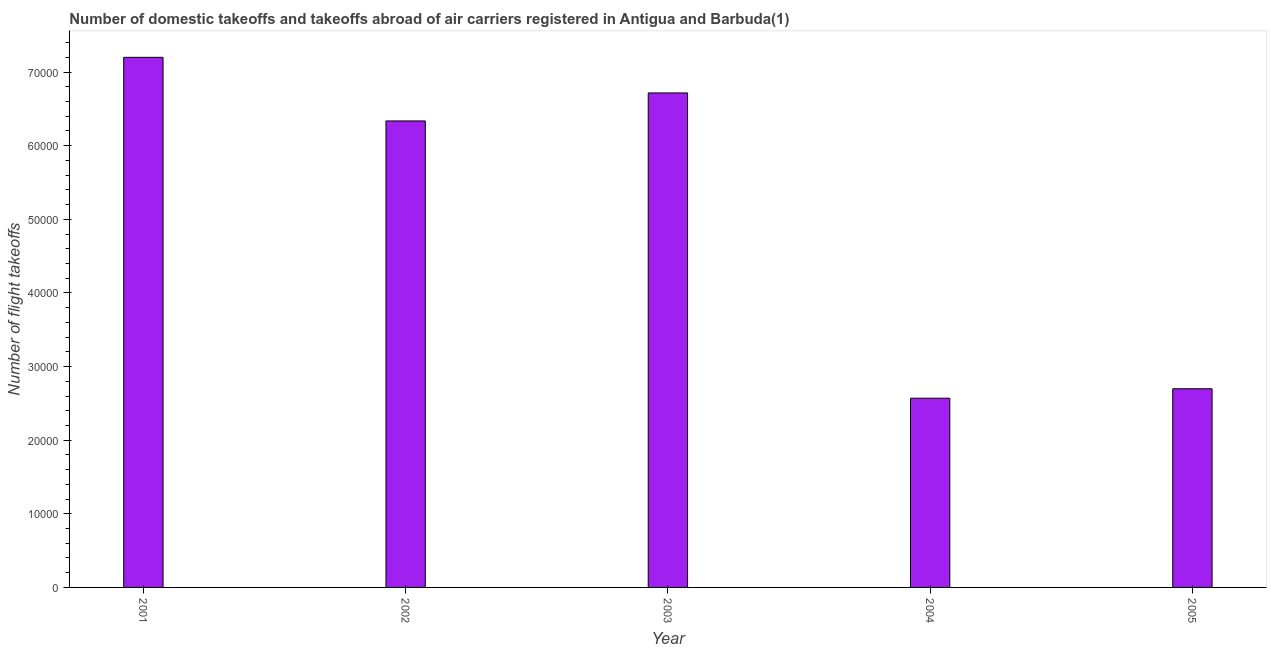What is the title of the graph?
Provide a succinct answer. Number of domestic takeoffs and takeoffs abroad of air carriers registered in Antigua and Barbuda(1). What is the label or title of the Y-axis?
Provide a succinct answer. Number of flight takeoffs. What is the number of flight takeoffs in 2001?
Provide a succinct answer. 7.20e+04. Across all years, what is the maximum number of flight takeoffs?
Provide a succinct answer. 7.20e+04. Across all years, what is the minimum number of flight takeoffs?
Provide a short and direct response. 2.57e+04. In which year was the number of flight takeoffs minimum?
Your answer should be very brief. 2004. What is the sum of the number of flight takeoffs?
Make the answer very short. 2.55e+05. What is the difference between the number of flight takeoffs in 2003 and 2005?
Give a very brief answer. 4.02e+04. What is the average number of flight takeoffs per year?
Offer a terse response. 5.10e+04. What is the median number of flight takeoffs?
Offer a very short reply. 6.34e+04. What is the ratio of the number of flight takeoffs in 2003 to that in 2005?
Keep it short and to the point. 2.49. Is the number of flight takeoffs in 2003 less than that in 2005?
Your response must be concise. No. What is the difference between the highest and the second highest number of flight takeoffs?
Give a very brief answer. 4838. Is the sum of the number of flight takeoffs in 2002 and 2005 greater than the maximum number of flight takeoffs across all years?
Offer a very short reply. Yes. What is the difference between the highest and the lowest number of flight takeoffs?
Offer a terse response. 4.63e+04. Are all the bars in the graph horizontal?
Your answer should be compact. No. How many years are there in the graph?
Your answer should be compact. 5. What is the Number of flight takeoffs in 2001?
Keep it short and to the point. 7.20e+04. What is the Number of flight takeoffs of 2002?
Offer a terse response. 6.34e+04. What is the Number of flight takeoffs in 2003?
Give a very brief answer. 6.72e+04. What is the Number of flight takeoffs in 2004?
Your answer should be very brief. 2.57e+04. What is the Number of flight takeoffs of 2005?
Provide a short and direct response. 2.70e+04. What is the difference between the Number of flight takeoffs in 2001 and 2002?
Provide a succinct answer. 8640. What is the difference between the Number of flight takeoffs in 2001 and 2003?
Your answer should be very brief. 4838. What is the difference between the Number of flight takeoffs in 2001 and 2004?
Ensure brevity in your answer.  4.63e+04. What is the difference between the Number of flight takeoffs in 2001 and 2005?
Give a very brief answer. 4.50e+04. What is the difference between the Number of flight takeoffs in 2002 and 2003?
Ensure brevity in your answer.  -3802. What is the difference between the Number of flight takeoffs in 2002 and 2004?
Ensure brevity in your answer.  3.77e+04. What is the difference between the Number of flight takeoffs in 2002 and 2005?
Keep it short and to the point. 3.64e+04. What is the difference between the Number of flight takeoffs in 2003 and 2004?
Your response must be concise. 4.15e+04. What is the difference between the Number of flight takeoffs in 2003 and 2005?
Your answer should be very brief. 4.02e+04. What is the difference between the Number of flight takeoffs in 2004 and 2005?
Offer a very short reply. -1285. What is the ratio of the Number of flight takeoffs in 2001 to that in 2002?
Keep it short and to the point. 1.14. What is the ratio of the Number of flight takeoffs in 2001 to that in 2003?
Make the answer very short. 1.07. What is the ratio of the Number of flight takeoffs in 2001 to that in 2004?
Provide a succinct answer. 2.8. What is the ratio of the Number of flight takeoffs in 2001 to that in 2005?
Offer a terse response. 2.67. What is the ratio of the Number of flight takeoffs in 2002 to that in 2003?
Provide a succinct answer. 0.94. What is the ratio of the Number of flight takeoffs in 2002 to that in 2004?
Offer a terse response. 2.46. What is the ratio of the Number of flight takeoffs in 2002 to that in 2005?
Your answer should be compact. 2.35. What is the ratio of the Number of flight takeoffs in 2003 to that in 2004?
Provide a short and direct response. 2.61. What is the ratio of the Number of flight takeoffs in 2003 to that in 2005?
Your answer should be compact. 2.49. What is the ratio of the Number of flight takeoffs in 2004 to that in 2005?
Offer a terse response. 0.95. 